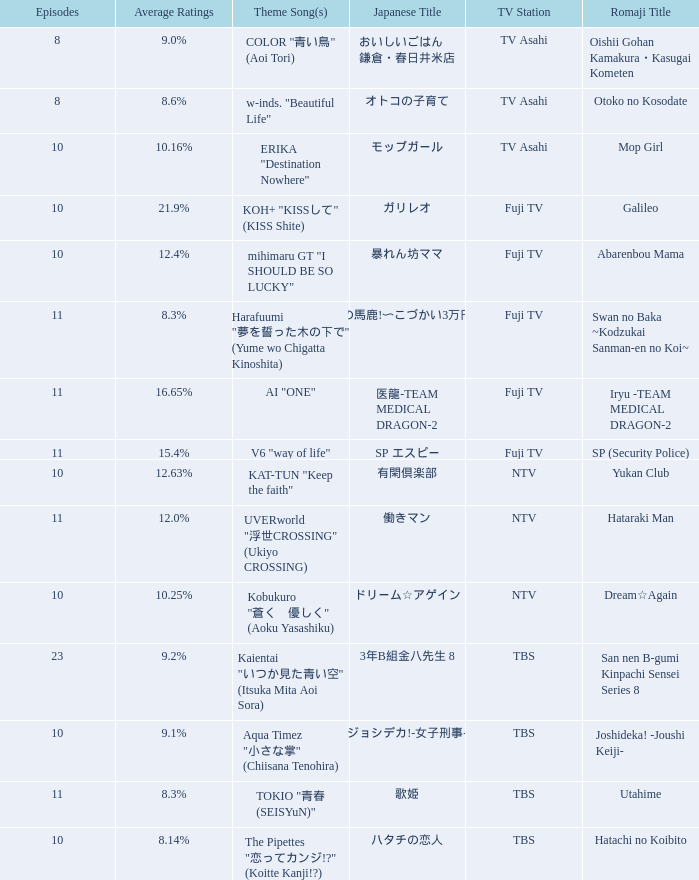What is the theme song of iryu - team medical dragon - 2? AI "ONE". 